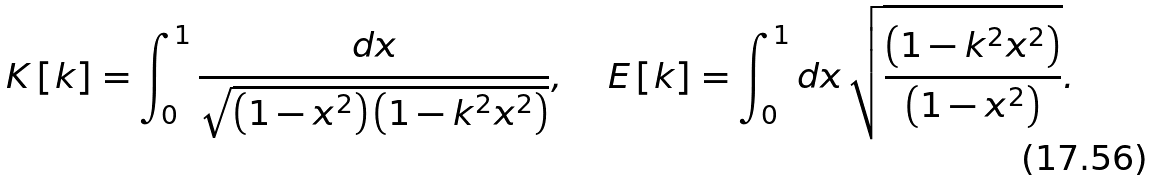<formula> <loc_0><loc_0><loc_500><loc_500>K \left [ k \right ] = \int _ { 0 } ^ { 1 } \frac { d x } { \sqrt { \left ( 1 - x ^ { 2 } \right ) \left ( 1 - k ^ { 2 } x ^ { 2 } \right ) } } , \quad \, E \left [ k \right ] = \int _ { 0 } ^ { 1 } d x \, \sqrt { \frac { \left ( 1 - k ^ { 2 } x ^ { 2 } \right ) } { \left ( 1 - x ^ { 2 } \right ) } } .</formula> 